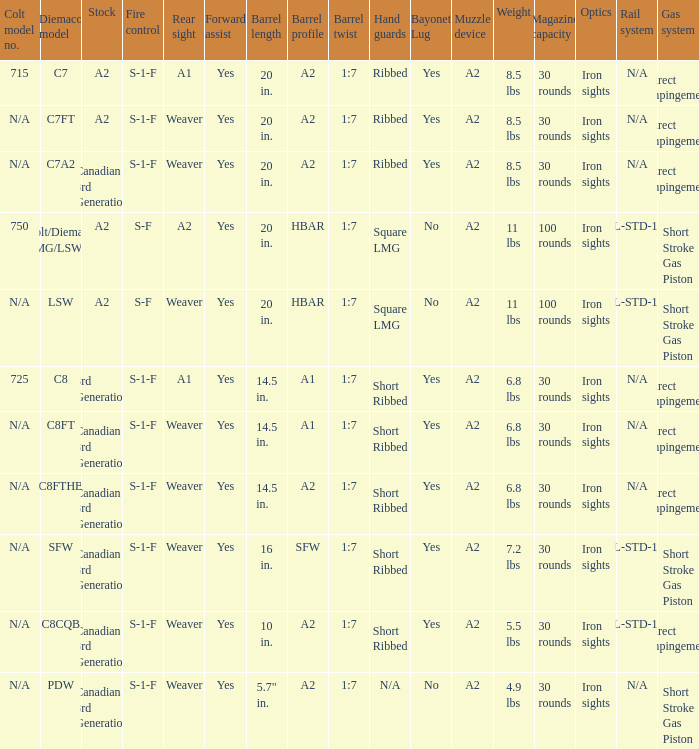Which Barrel twist has a Stock of canadian 3rd generation and a Hand guards of short ribbed? 1:7, 1:7, 1:7, 1:7. 